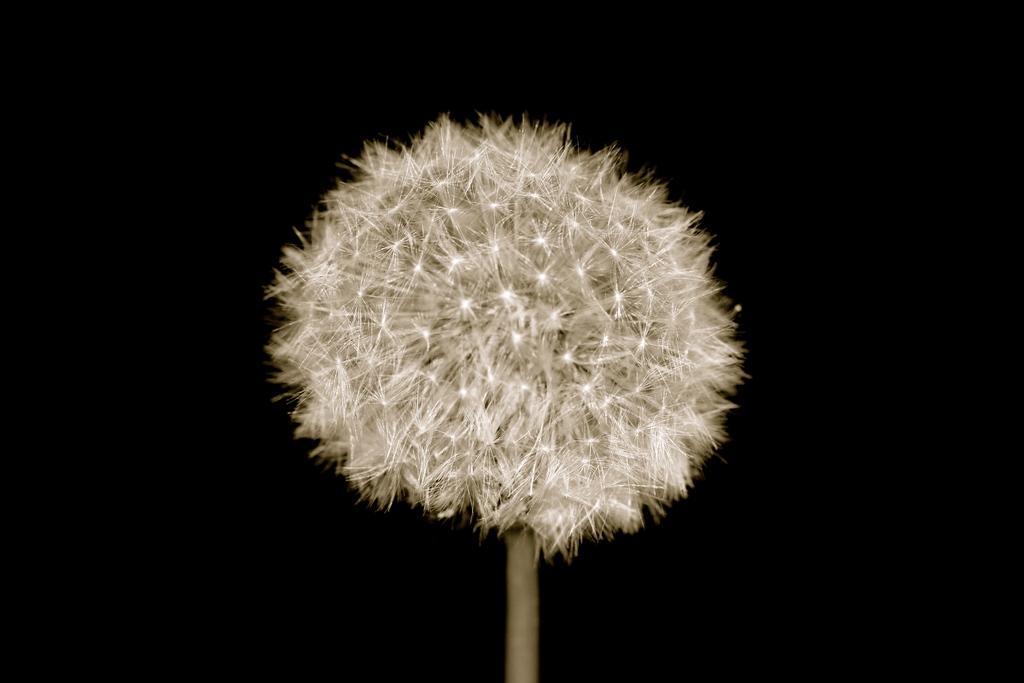Describe this image in one or two sentences. In this picture I can see there is a dandelion, it is attached with to a stem and the backdrop is dark. 